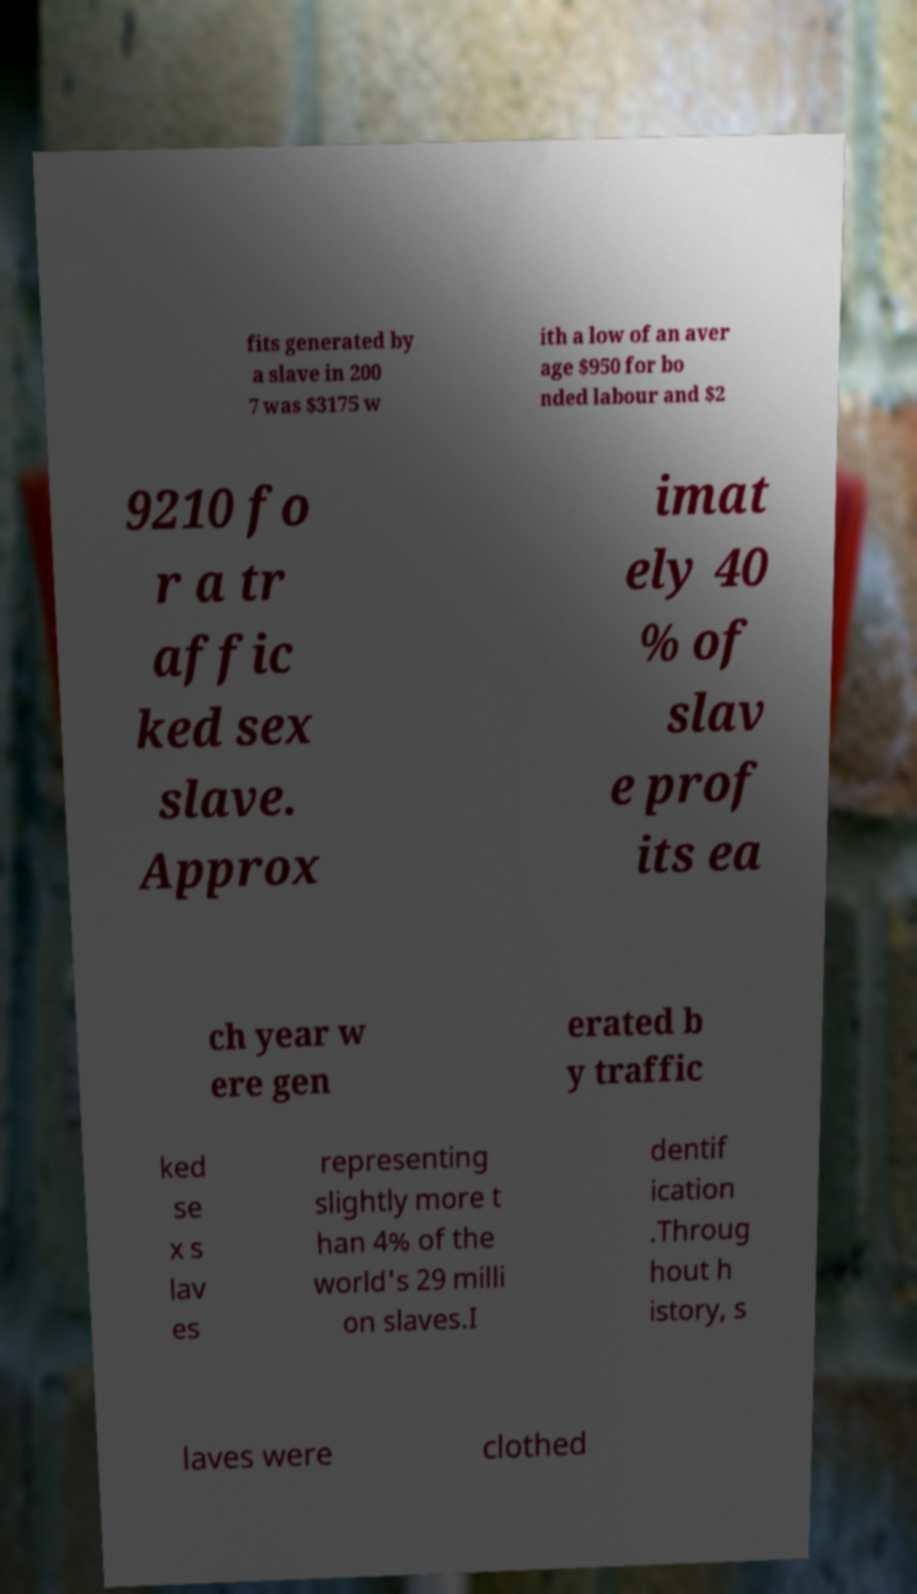Please read and relay the text visible in this image. What does it say? fits generated by a slave in 200 7 was $3175 w ith a low of an aver age $950 for bo nded labour and $2 9210 fo r a tr affic ked sex slave. Approx imat ely 40 % of slav e prof its ea ch year w ere gen erated b y traffic ked se x s lav es representing slightly more t han 4% of the world's 29 milli on slaves.I dentif ication .Throug hout h istory, s laves were clothed 